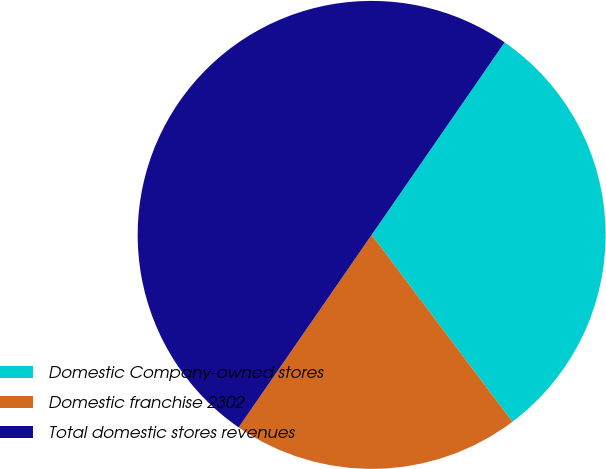Convert chart to OTSL. <chart><loc_0><loc_0><loc_500><loc_500><pie_chart><fcel>Domestic Company-owned stores<fcel>Domestic franchise 2302<fcel>Total domestic stores revenues<nl><fcel>30.1%<fcel>19.9%<fcel>50.0%<nl></chart> 